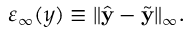Convert formula to latex. <formula><loc_0><loc_0><loc_500><loc_500>\varepsilon _ { \infty } ( y ) \equiv \| \hat { y } - \tilde { y } \| _ { \infty } .</formula> 